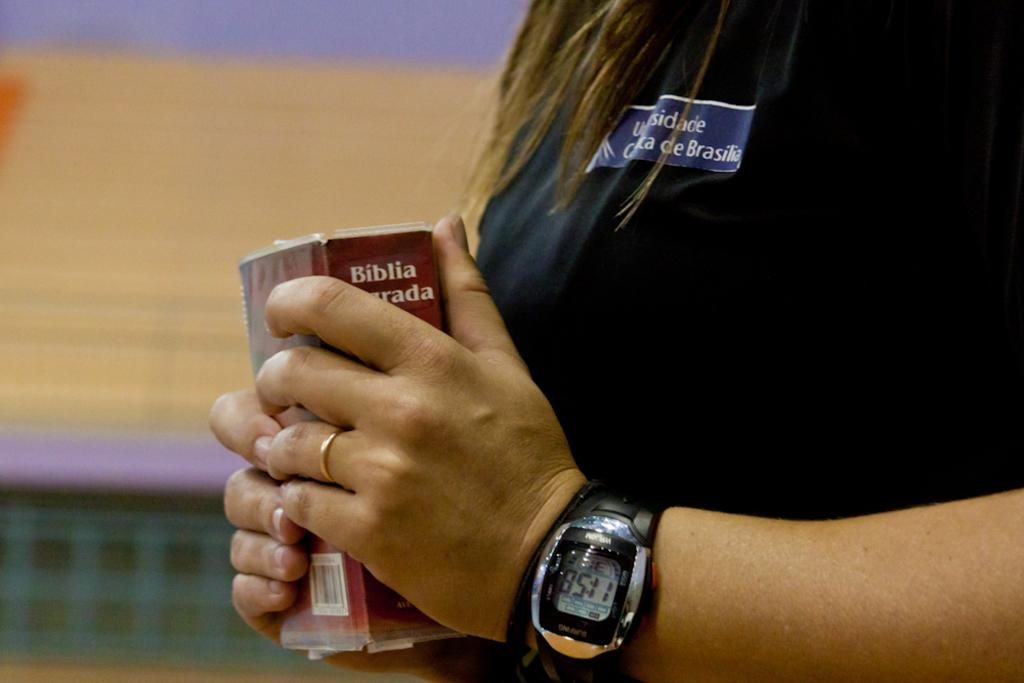<image>
Write a terse but informative summary of the picture. A woman holding a book that says Biblia on it. 